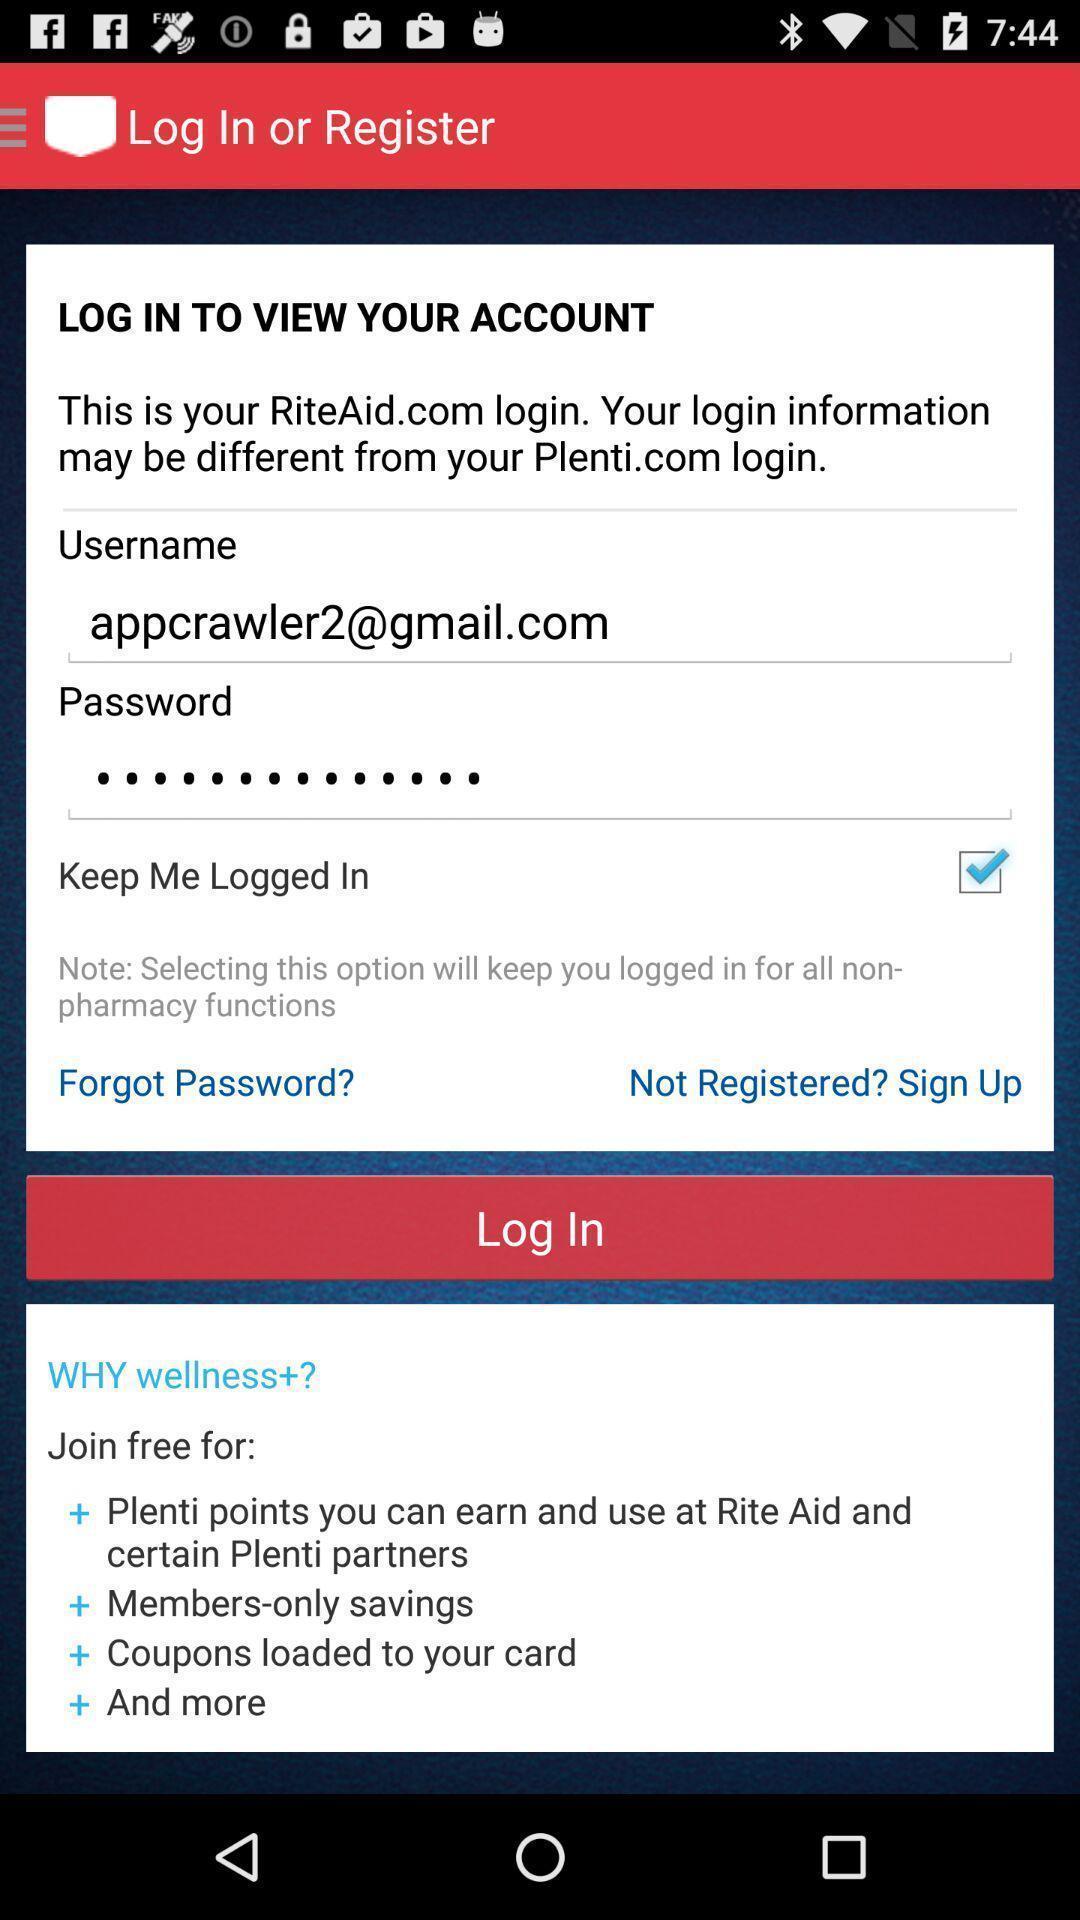Tell me about the visual elements in this screen capture. Screen showing log in page. 